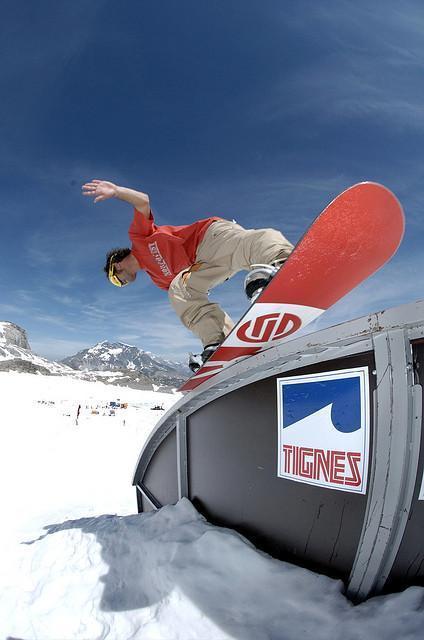Is this affirmation: "The person is in the boat." correct?
Answer yes or no. No. 